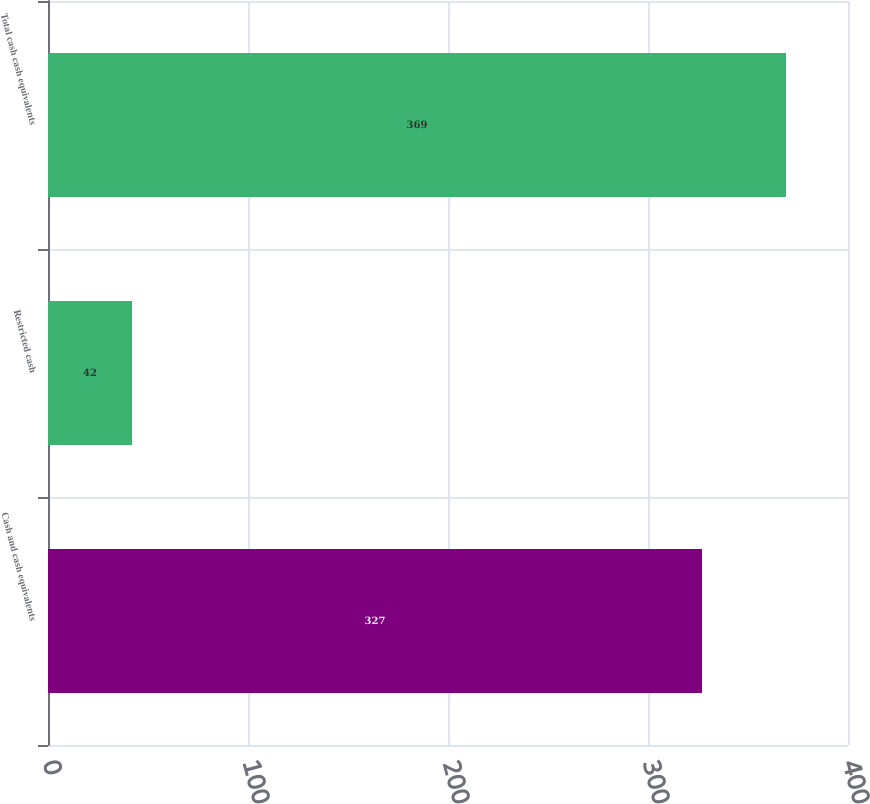Convert chart. <chart><loc_0><loc_0><loc_500><loc_500><bar_chart><fcel>Cash and cash equivalents<fcel>Restricted cash<fcel>Total cash cash equivalents<nl><fcel>327<fcel>42<fcel>369<nl></chart> 